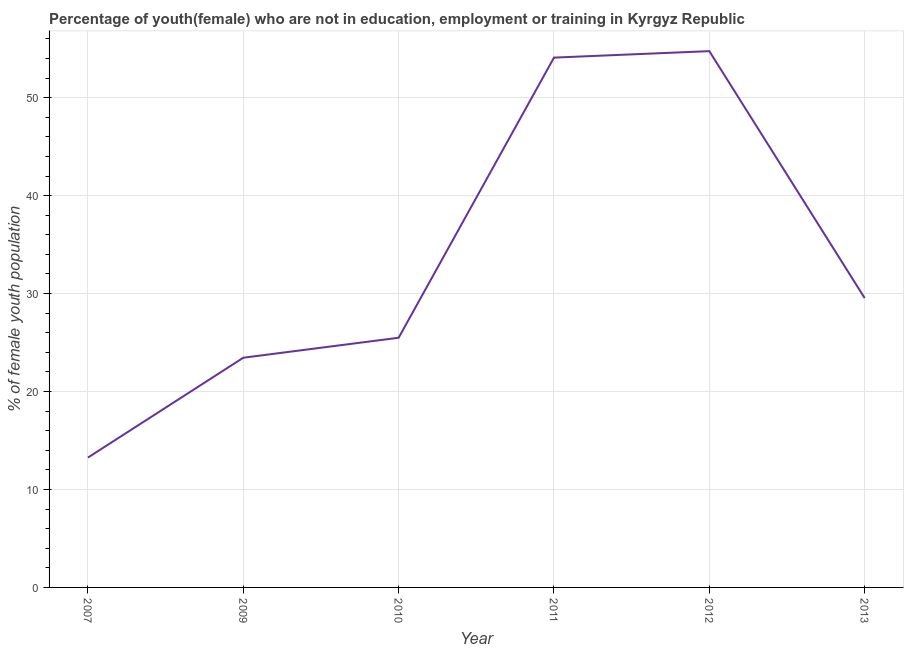What is the unemployed female youth population in 2013?
Keep it short and to the point. 29.54. Across all years, what is the maximum unemployed female youth population?
Your answer should be compact. 54.75. Across all years, what is the minimum unemployed female youth population?
Make the answer very short. 13.26. What is the sum of the unemployed female youth population?
Offer a terse response. 200.58. What is the difference between the unemployed female youth population in 2007 and 2012?
Offer a very short reply. -41.49. What is the average unemployed female youth population per year?
Your answer should be very brief. 33.43. What is the median unemployed female youth population?
Keep it short and to the point. 27.52. What is the ratio of the unemployed female youth population in 2009 to that in 2012?
Give a very brief answer. 0.43. Is the unemployed female youth population in 2012 less than that in 2013?
Your response must be concise. No. What is the difference between the highest and the second highest unemployed female youth population?
Make the answer very short. 0.66. What is the difference between the highest and the lowest unemployed female youth population?
Your answer should be very brief. 41.49. In how many years, is the unemployed female youth population greater than the average unemployed female youth population taken over all years?
Your answer should be compact. 2. Does the unemployed female youth population monotonically increase over the years?
Offer a terse response. No. How many lines are there?
Give a very brief answer. 1. How many years are there in the graph?
Give a very brief answer. 6. What is the difference between two consecutive major ticks on the Y-axis?
Ensure brevity in your answer.  10. Does the graph contain grids?
Your answer should be very brief. Yes. What is the title of the graph?
Give a very brief answer. Percentage of youth(female) who are not in education, employment or training in Kyrgyz Republic. What is the label or title of the Y-axis?
Give a very brief answer. % of female youth population. What is the % of female youth population in 2007?
Provide a short and direct response. 13.26. What is the % of female youth population of 2009?
Keep it short and to the point. 23.45. What is the % of female youth population in 2010?
Provide a short and direct response. 25.49. What is the % of female youth population in 2011?
Your answer should be compact. 54.09. What is the % of female youth population in 2012?
Your answer should be compact. 54.75. What is the % of female youth population of 2013?
Ensure brevity in your answer.  29.54. What is the difference between the % of female youth population in 2007 and 2009?
Keep it short and to the point. -10.19. What is the difference between the % of female youth population in 2007 and 2010?
Offer a terse response. -12.23. What is the difference between the % of female youth population in 2007 and 2011?
Offer a very short reply. -40.83. What is the difference between the % of female youth population in 2007 and 2012?
Your answer should be compact. -41.49. What is the difference between the % of female youth population in 2007 and 2013?
Your answer should be compact. -16.28. What is the difference between the % of female youth population in 2009 and 2010?
Ensure brevity in your answer.  -2.04. What is the difference between the % of female youth population in 2009 and 2011?
Provide a short and direct response. -30.64. What is the difference between the % of female youth population in 2009 and 2012?
Your answer should be very brief. -31.3. What is the difference between the % of female youth population in 2009 and 2013?
Make the answer very short. -6.09. What is the difference between the % of female youth population in 2010 and 2011?
Your response must be concise. -28.6. What is the difference between the % of female youth population in 2010 and 2012?
Your response must be concise. -29.26. What is the difference between the % of female youth population in 2010 and 2013?
Offer a very short reply. -4.05. What is the difference between the % of female youth population in 2011 and 2012?
Provide a succinct answer. -0.66. What is the difference between the % of female youth population in 2011 and 2013?
Your answer should be compact. 24.55. What is the difference between the % of female youth population in 2012 and 2013?
Ensure brevity in your answer.  25.21. What is the ratio of the % of female youth population in 2007 to that in 2009?
Give a very brief answer. 0.56. What is the ratio of the % of female youth population in 2007 to that in 2010?
Your response must be concise. 0.52. What is the ratio of the % of female youth population in 2007 to that in 2011?
Provide a succinct answer. 0.24. What is the ratio of the % of female youth population in 2007 to that in 2012?
Your response must be concise. 0.24. What is the ratio of the % of female youth population in 2007 to that in 2013?
Offer a very short reply. 0.45. What is the ratio of the % of female youth population in 2009 to that in 2011?
Offer a very short reply. 0.43. What is the ratio of the % of female youth population in 2009 to that in 2012?
Provide a succinct answer. 0.43. What is the ratio of the % of female youth population in 2009 to that in 2013?
Your answer should be compact. 0.79. What is the ratio of the % of female youth population in 2010 to that in 2011?
Give a very brief answer. 0.47. What is the ratio of the % of female youth population in 2010 to that in 2012?
Your answer should be very brief. 0.47. What is the ratio of the % of female youth population in 2010 to that in 2013?
Your response must be concise. 0.86. What is the ratio of the % of female youth population in 2011 to that in 2013?
Your answer should be compact. 1.83. What is the ratio of the % of female youth population in 2012 to that in 2013?
Give a very brief answer. 1.85. 